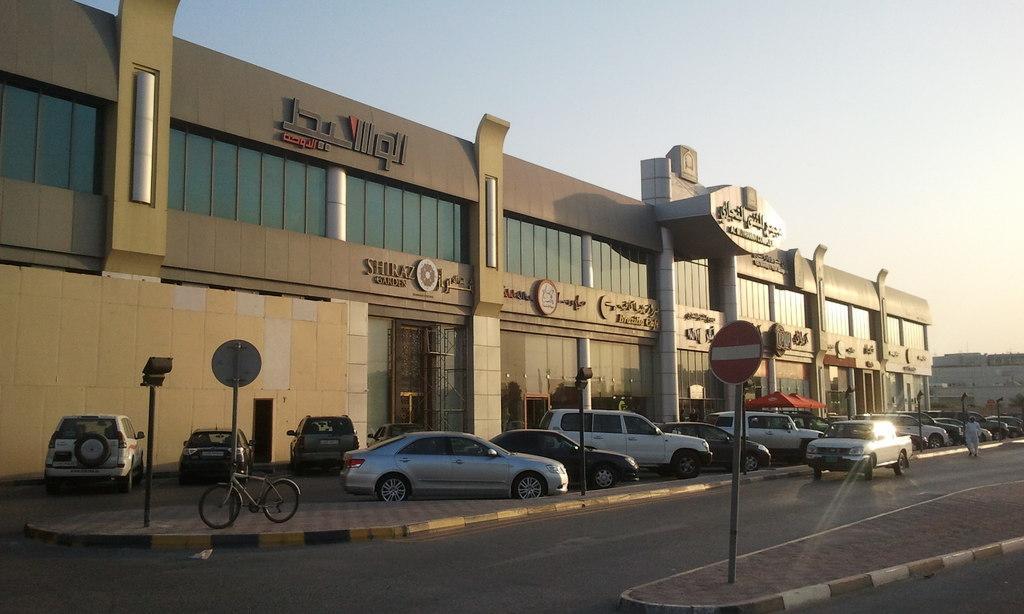How would you summarize this image in a sentence or two? In this image we can see a store. There are many vehicles parked. A car is moving on the road. A person is walking on the road. There is a blue sky in the image. 